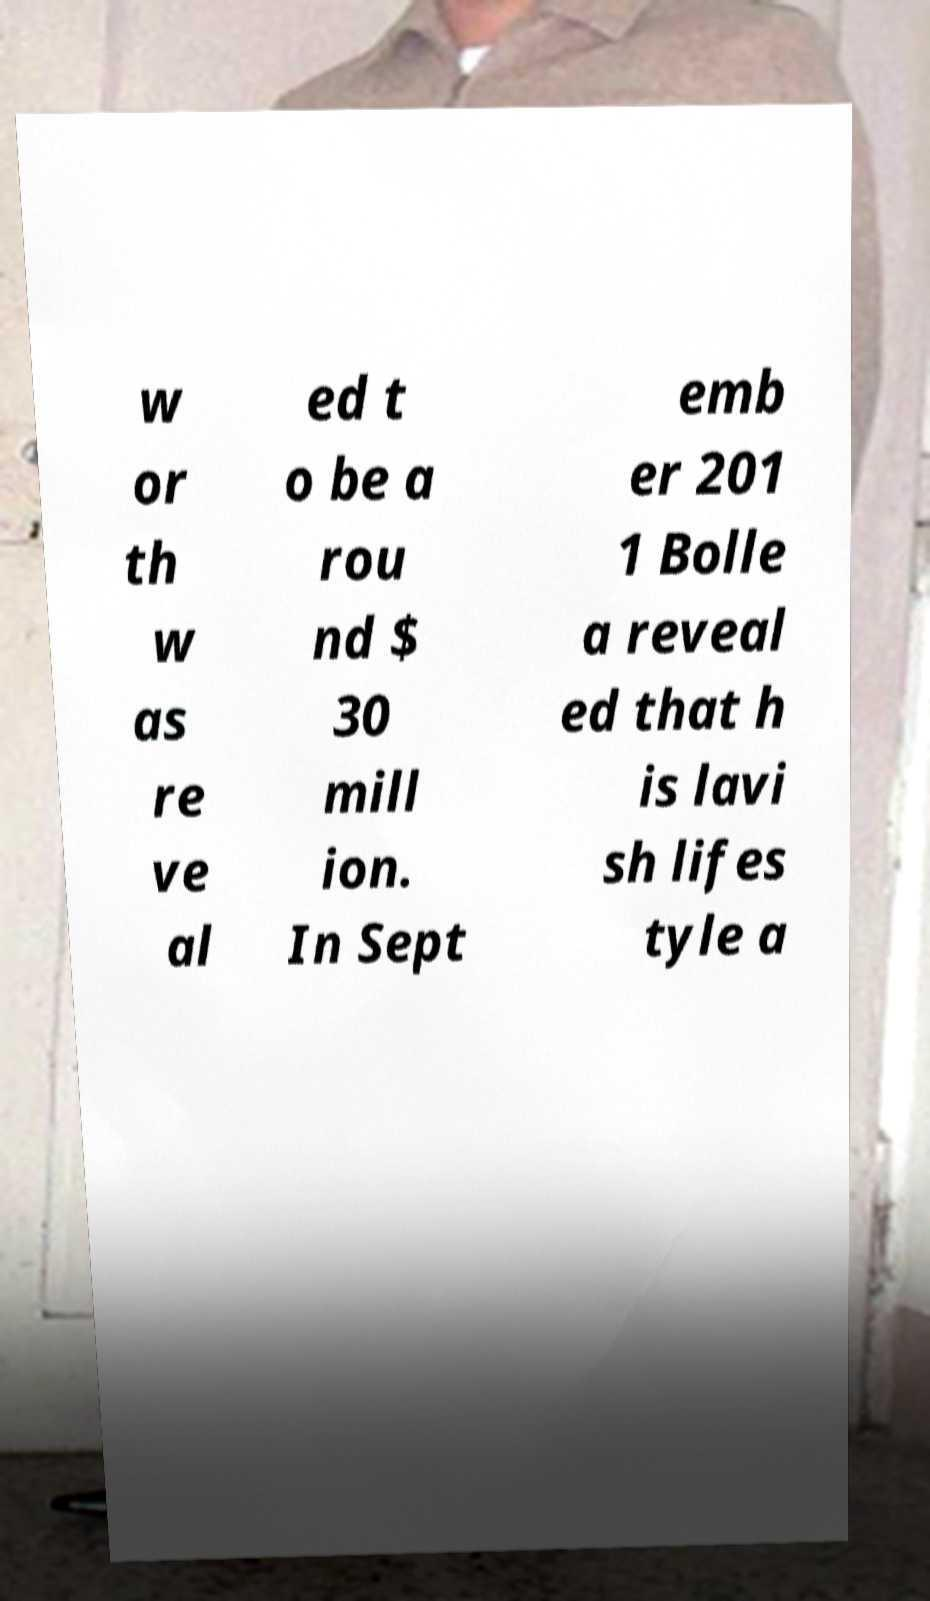There's text embedded in this image that I need extracted. Can you transcribe it verbatim? w or th w as re ve al ed t o be a rou nd $ 30 mill ion. In Sept emb er 201 1 Bolle a reveal ed that h is lavi sh lifes tyle a 